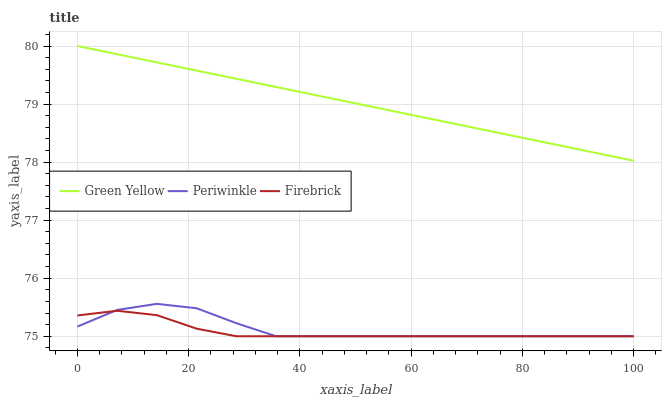Does Firebrick have the minimum area under the curve?
Answer yes or no. Yes. Does Green Yellow have the maximum area under the curve?
Answer yes or no. Yes. Does Periwinkle have the minimum area under the curve?
Answer yes or no. No. Does Periwinkle have the maximum area under the curve?
Answer yes or no. No. Is Green Yellow the smoothest?
Answer yes or no. Yes. Is Periwinkle the roughest?
Answer yes or no. Yes. Is Periwinkle the smoothest?
Answer yes or no. No. Is Green Yellow the roughest?
Answer yes or no. No. Does Firebrick have the lowest value?
Answer yes or no. Yes. Does Green Yellow have the lowest value?
Answer yes or no. No. Does Green Yellow have the highest value?
Answer yes or no. Yes. Does Periwinkle have the highest value?
Answer yes or no. No. Is Periwinkle less than Green Yellow?
Answer yes or no. Yes. Is Green Yellow greater than Periwinkle?
Answer yes or no. Yes. Does Firebrick intersect Periwinkle?
Answer yes or no. Yes. Is Firebrick less than Periwinkle?
Answer yes or no. No. Is Firebrick greater than Periwinkle?
Answer yes or no. No. Does Periwinkle intersect Green Yellow?
Answer yes or no. No. 